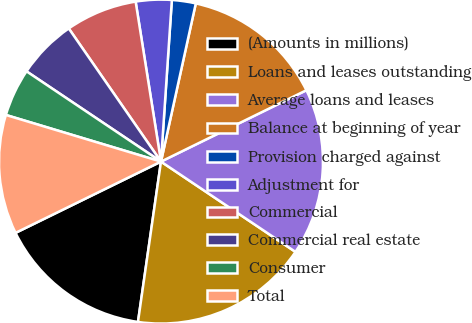Convert chart. <chart><loc_0><loc_0><loc_500><loc_500><pie_chart><fcel>(Amounts in millions)<fcel>Loans and leases outstanding<fcel>Average loans and leases<fcel>Balance at beginning of year<fcel>Provision charged against<fcel>Adjustment for<fcel>Commercial<fcel>Commercial real estate<fcel>Consumer<fcel>Total<nl><fcel>15.48%<fcel>17.86%<fcel>16.67%<fcel>14.29%<fcel>2.38%<fcel>3.57%<fcel>7.14%<fcel>5.95%<fcel>4.76%<fcel>11.9%<nl></chart> 